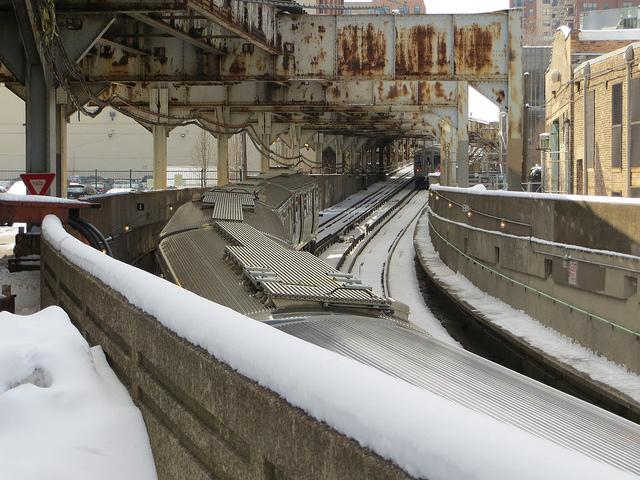What is located above the ironwork on top of the train that is heading away? bridge 